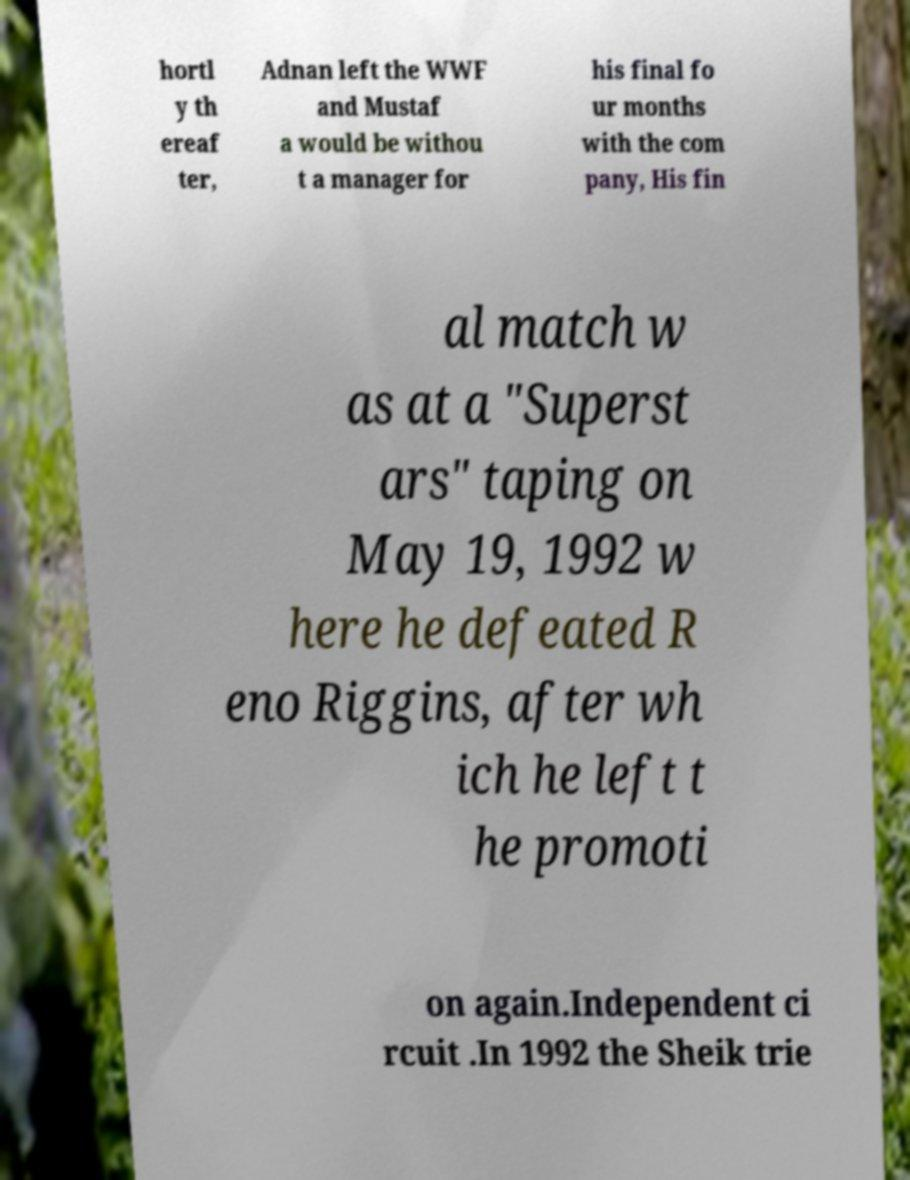For documentation purposes, I need the text within this image transcribed. Could you provide that? hortl y th ereaf ter, Adnan left the WWF and Mustaf a would be withou t a manager for his final fo ur months with the com pany, His fin al match w as at a "Superst ars" taping on May 19, 1992 w here he defeated R eno Riggins, after wh ich he left t he promoti on again.Independent ci rcuit .In 1992 the Sheik trie 